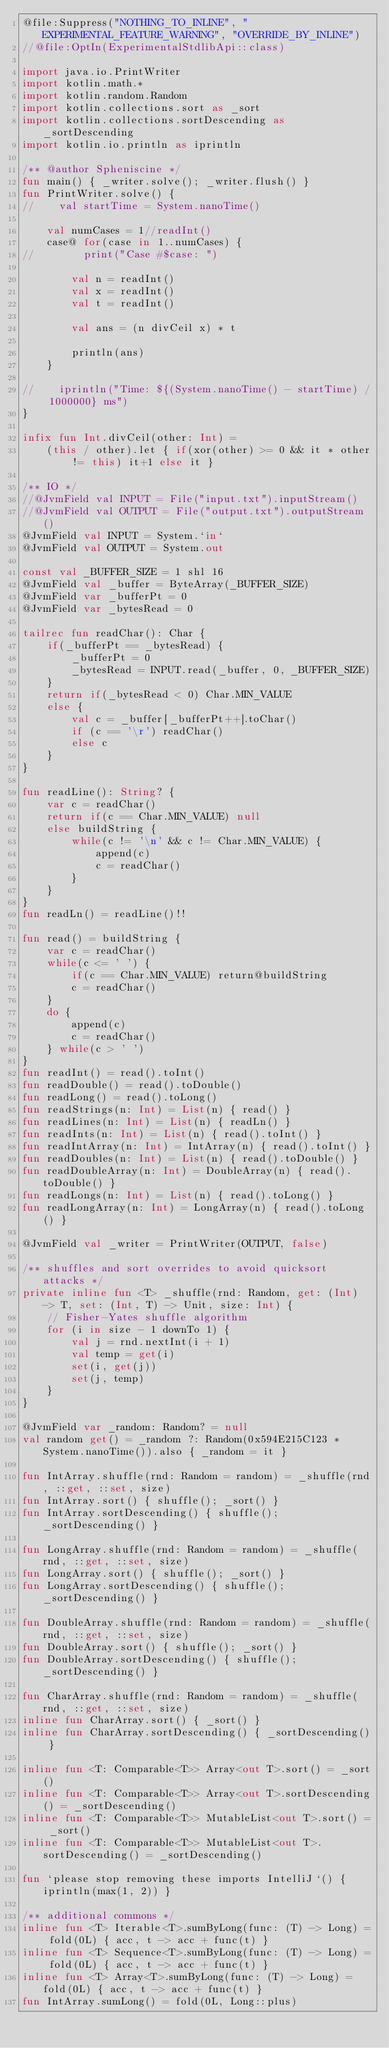Convert code to text. <code><loc_0><loc_0><loc_500><loc_500><_Kotlin_>@file:Suppress("NOTHING_TO_INLINE", "EXPERIMENTAL_FEATURE_WARNING", "OVERRIDE_BY_INLINE")
//@file:OptIn(ExperimentalStdlibApi::class)

import java.io.PrintWriter
import kotlin.math.*
import kotlin.random.Random
import kotlin.collections.sort as _sort
import kotlin.collections.sortDescending as _sortDescending
import kotlin.io.println as iprintln

/** @author Spheniscine */
fun main() { _writer.solve(); _writer.flush() }
fun PrintWriter.solve() {
//    val startTime = System.nanoTime()

    val numCases = 1//readInt()
    case@ for(case in 1..numCases) {
//        print("Case #$case: ")

        val n = readInt()
        val x = readInt()
        val t = readInt()

        val ans = (n divCeil x) * t

        println(ans)
    }

//    iprintln("Time: ${(System.nanoTime() - startTime) / 1000000} ms")
}

infix fun Int.divCeil(other: Int) =
    (this / other).let { if(xor(other) >= 0 && it * other != this) it+1 else it }

/** IO */
//@JvmField val INPUT = File("input.txt").inputStream()
//@JvmField val OUTPUT = File("output.txt").outputStream()
@JvmField val INPUT = System.`in`
@JvmField val OUTPUT = System.out

const val _BUFFER_SIZE = 1 shl 16
@JvmField val _buffer = ByteArray(_BUFFER_SIZE)
@JvmField var _bufferPt = 0
@JvmField var _bytesRead = 0

tailrec fun readChar(): Char {
    if(_bufferPt == _bytesRead) {
        _bufferPt = 0
        _bytesRead = INPUT.read(_buffer, 0, _BUFFER_SIZE)
    }
    return if(_bytesRead < 0) Char.MIN_VALUE
    else {
        val c = _buffer[_bufferPt++].toChar()
        if (c == '\r') readChar()
        else c
    }
}

fun readLine(): String? {
    var c = readChar()
    return if(c == Char.MIN_VALUE) null
    else buildString {
        while(c != '\n' && c != Char.MIN_VALUE) {
            append(c)
            c = readChar()
        }
    }
}
fun readLn() = readLine()!!

fun read() = buildString {
    var c = readChar()
    while(c <= ' ') {
        if(c == Char.MIN_VALUE) return@buildString
        c = readChar()
    }
    do {
        append(c)
        c = readChar()
    } while(c > ' ')
}
fun readInt() = read().toInt()
fun readDouble() = read().toDouble()
fun readLong() = read().toLong()
fun readStrings(n: Int) = List(n) { read() }
fun readLines(n: Int) = List(n) { readLn() }
fun readInts(n: Int) = List(n) { read().toInt() }
fun readIntArray(n: Int) = IntArray(n) { read().toInt() }
fun readDoubles(n: Int) = List(n) { read().toDouble() }
fun readDoubleArray(n: Int) = DoubleArray(n) { read().toDouble() }
fun readLongs(n: Int) = List(n) { read().toLong() }
fun readLongArray(n: Int) = LongArray(n) { read().toLong() }

@JvmField val _writer = PrintWriter(OUTPUT, false)

/** shuffles and sort overrides to avoid quicksort attacks */
private inline fun <T> _shuffle(rnd: Random, get: (Int) -> T, set: (Int, T) -> Unit, size: Int) {
    // Fisher-Yates shuffle algorithm
    for (i in size - 1 downTo 1) {
        val j = rnd.nextInt(i + 1)
        val temp = get(i)
        set(i, get(j))
        set(j, temp)
    }
}

@JvmField var _random: Random? = null
val random get() = _random ?: Random(0x594E215C123 * System.nanoTime()).also { _random = it }

fun IntArray.shuffle(rnd: Random = random) = _shuffle(rnd, ::get, ::set, size)
fun IntArray.sort() { shuffle(); _sort() }
fun IntArray.sortDescending() { shuffle(); _sortDescending() }

fun LongArray.shuffle(rnd: Random = random) = _shuffle(rnd, ::get, ::set, size)
fun LongArray.sort() { shuffle(); _sort() }
fun LongArray.sortDescending() { shuffle(); _sortDescending() }

fun DoubleArray.shuffle(rnd: Random = random) = _shuffle(rnd, ::get, ::set, size)
fun DoubleArray.sort() { shuffle(); _sort() }
fun DoubleArray.sortDescending() { shuffle(); _sortDescending() }

fun CharArray.shuffle(rnd: Random = random) = _shuffle(rnd, ::get, ::set, size)
inline fun CharArray.sort() { _sort() }
inline fun CharArray.sortDescending() { _sortDescending() }

inline fun <T: Comparable<T>> Array<out T>.sort() = _sort()
inline fun <T: Comparable<T>> Array<out T>.sortDescending() = _sortDescending()
inline fun <T: Comparable<T>> MutableList<out T>.sort() = _sort()
inline fun <T: Comparable<T>> MutableList<out T>.sortDescending() = _sortDescending()

fun `please stop removing these imports IntelliJ`() { iprintln(max(1, 2)) }

/** additional commons */
inline fun <T> Iterable<T>.sumByLong(func: (T) -> Long) = fold(0L) { acc, t -> acc + func(t) }
inline fun <T> Sequence<T>.sumByLong(func: (T) -> Long) = fold(0L) { acc, t -> acc + func(t) }
inline fun <T> Array<T>.sumByLong(func: (T) -> Long) = fold(0L) { acc, t -> acc + func(t) }
fun IntArray.sumLong() = fold(0L, Long::plus)</code> 